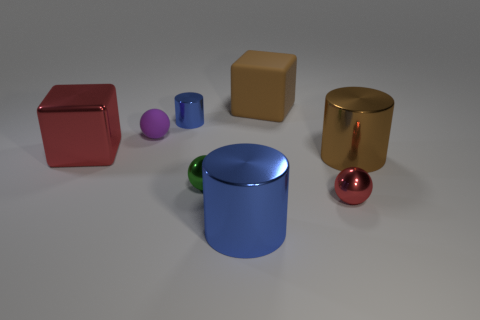The large thing in front of the brown metal object has what shape?
Offer a terse response. Cylinder. What size is the ball that is the same color as the large metallic cube?
Offer a terse response. Small. Is there a metallic object of the same size as the brown metallic cylinder?
Give a very brief answer. Yes. Do the small sphere right of the large matte cube and the small green sphere have the same material?
Your response must be concise. Yes. Are there an equal number of purple balls that are in front of the red block and big metal blocks on the right side of the red metal ball?
Keep it short and to the point. Yes. What shape is the metal object that is to the right of the red shiny block and to the left of the green object?
Keep it short and to the point. Cylinder. How many green things are on the right side of the tiny purple ball?
Offer a very short reply. 1. What number of other things are the same shape as the purple object?
Keep it short and to the point. 2. Is the number of small green metallic objects less than the number of yellow objects?
Your answer should be compact. No. What is the size of the metal object that is left of the green metallic ball and in front of the small purple matte ball?
Your answer should be very brief. Large. 